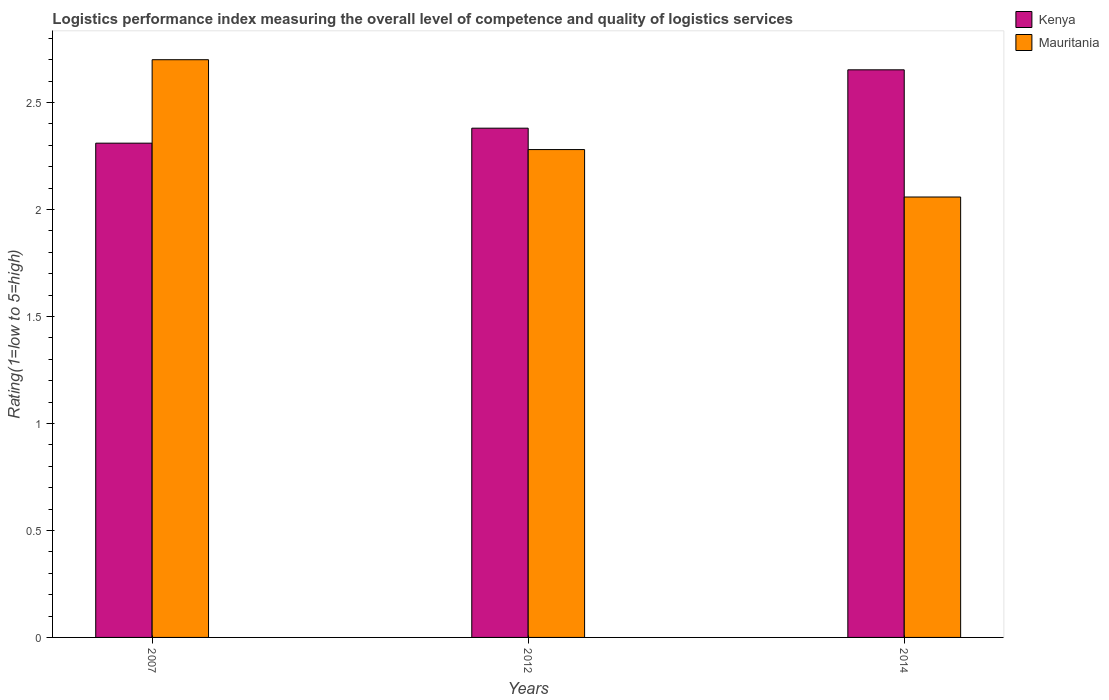How many groups of bars are there?
Your response must be concise. 3. Are the number of bars on each tick of the X-axis equal?
Ensure brevity in your answer.  Yes. How many bars are there on the 1st tick from the right?
Ensure brevity in your answer.  2. What is the label of the 1st group of bars from the left?
Provide a short and direct response. 2007. What is the Logistic performance index in Kenya in 2012?
Provide a short and direct response. 2.38. Across all years, what is the maximum Logistic performance index in Kenya?
Your response must be concise. 2.65. Across all years, what is the minimum Logistic performance index in Mauritania?
Make the answer very short. 2.06. In which year was the Logistic performance index in Kenya maximum?
Your answer should be compact. 2014. In which year was the Logistic performance index in Kenya minimum?
Your response must be concise. 2007. What is the total Logistic performance index in Kenya in the graph?
Offer a very short reply. 7.34. What is the difference between the Logistic performance index in Kenya in 2007 and that in 2012?
Your answer should be compact. -0.07. What is the difference between the Logistic performance index in Mauritania in 2007 and the Logistic performance index in Kenya in 2014?
Your answer should be very brief. 0.05. What is the average Logistic performance index in Mauritania per year?
Provide a short and direct response. 2.35. In the year 2014, what is the difference between the Logistic performance index in Kenya and Logistic performance index in Mauritania?
Your answer should be very brief. 0.59. What is the ratio of the Logistic performance index in Mauritania in 2007 to that in 2014?
Your answer should be very brief. 1.31. What is the difference between the highest and the second highest Logistic performance index in Mauritania?
Offer a very short reply. 0.42. What is the difference between the highest and the lowest Logistic performance index in Mauritania?
Ensure brevity in your answer.  0.64. In how many years, is the Logistic performance index in Kenya greater than the average Logistic performance index in Kenya taken over all years?
Your response must be concise. 1. What does the 2nd bar from the left in 2014 represents?
Your answer should be very brief. Mauritania. What does the 1st bar from the right in 2012 represents?
Provide a succinct answer. Mauritania. Are all the bars in the graph horizontal?
Offer a terse response. No. How many years are there in the graph?
Your response must be concise. 3. Are the values on the major ticks of Y-axis written in scientific E-notation?
Ensure brevity in your answer.  No. Where does the legend appear in the graph?
Your answer should be very brief. Top right. What is the title of the graph?
Your answer should be compact. Logistics performance index measuring the overall level of competence and quality of logistics services. What is the label or title of the Y-axis?
Your response must be concise. Rating(1=low to 5=high). What is the Rating(1=low to 5=high) in Kenya in 2007?
Offer a terse response. 2.31. What is the Rating(1=low to 5=high) in Kenya in 2012?
Your answer should be very brief. 2.38. What is the Rating(1=low to 5=high) of Mauritania in 2012?
Provide a succinct answer. 2.28. What is the Rating(1=low to 5=high) of Kenya in 2014?
Provide a succinct answer. 2.65. What is the Rating(1=low to 5=high) in Mauritania in 2014?
Your answer should be compact. 2.06. Across all years, what is the maximum Rating(1=low to 5=high) of Kenya?
Your answer should be compact. 2.65. Across all years, what is the minimum Rating(1=low to 5=high) in Kenya?
Provide a succinct answer. 2.31. Across all years, what is the minimum Rating(1=low to 5=high) of Mauritania?
Your answer should be very brief. 2.06. What is the total Rating(1=low to 5=high) of Kenya in the graph?
Provide a succinct answer. 7.34. What is the total Rating(1=low to 5=high) in Mauritania in the graph?
Provide a short and direct response. 7.04. What is the difference between the Rating(1=low to 5=high) of Kenya in 2007 and that in 2012?
Ensure brevity in your answer.  -0.07. What is the difference between the Rating(1=low to 5=high) of Mauritania in 2007 and that in 2012?
Give a very brief answer. 0.42. What is the difference between the Rating(1=low to 5=high) of Kenya in 2007 and that in 2014?
Your answer should be compact. -0.34. What is the difference between the Rating(1=low to 5=high) of Mauritania in 2007 and that in 2014?
Your answer should be compact. 0.64. What is the difference between the Rating(1=low to 5=high) of Kenya in 2012 and that in 2014?
Ensure brevity in your answer.  -0.27. What is the difference between the Rating(1=low to 5=high) in Mauritania in 2012 and that in 2014?
Your response must be concise. 0.22. What is the difference between the Rating(1=low to 5=high) of Kenya in 2007 and the Rating(1=low to 5=high) of Mauritania in 2012?
Make the answer very short. 0.03. What is the difference between the Rating(1=low to 5=high) in Kenya in 2007 and the Rating(1=low to 5=high) in Mauritania in 2014?
Offer a very short reply. 0.25. What is the difference between the Rating(1=low to 5=high) of Kenya in 2012 and the Rating(1=low to 5=high) of Mauritania in 2014?
Ensure brevity in your answer.  0.32. What is the average Rating(1=low to 5=high) in Kenya per year?
Offer a very short reply. 2.45. What is the average Rating(1=low to 5=high) in Mauritania per year?
Your answer should be very brief. 2.35. In the year 2007, what is the difference between the Rating(1=low to 5=high) in Kenya and Rating(1=low to 5=high) in Mauritania?
Make the answer very short. -0.39. In the year 2014, what is the difference between the Rating(1=low to 5=high) in Kenya and Rating(1=low to 5=high) in Mauritania?
Offer a terse response. 0.59. What is the ratio of the Rating(1=low to 5=high) of Kenya in 2007 to that in 2012?
Your answer should be very brief. 0.97. What is the ratio of the Rating(1=low to 5=high) of Mauritania in 2007 to that in 2012?
Your response must be concise. 1.18. What is the ratio of the Rating(1=low to 5=high) of Kenya in 2007 to that in 2014?
Keep it short and to the point. 0.87. What is the ratio of the Rating(1=low to 5=high) of Mauritania in 2007 to that in 2014?
Make the answer very short. 1.31. What is the ratio of the Rating(1=low to 5=high) in Kenya in 2012 to that in 2014?
Your response must be concise. 0.9. What is the ratio of the Rating(1=low to 5=high) of Mauritania in 2012 to that in 2014?
Make the answer very short. 1.11. What is the difference between the highest and the second highest Rating(1=low to 5=high) of Kenya?
Your answer should be compact. 0.27. What is the difference between the highest and the second highest Rating(1=low to 5=high) in Mauritania?
Keep it short and to the point. 0.42. What is the difference between the highest and the lowest Rating(1=low to 5=high) of Kenya?
Give a very brief answer. 0.34. What is the difference between the highest and the lowest Rating(1=low to 5=high) of Mauritania?
Your answer should be compact. 0.64. 